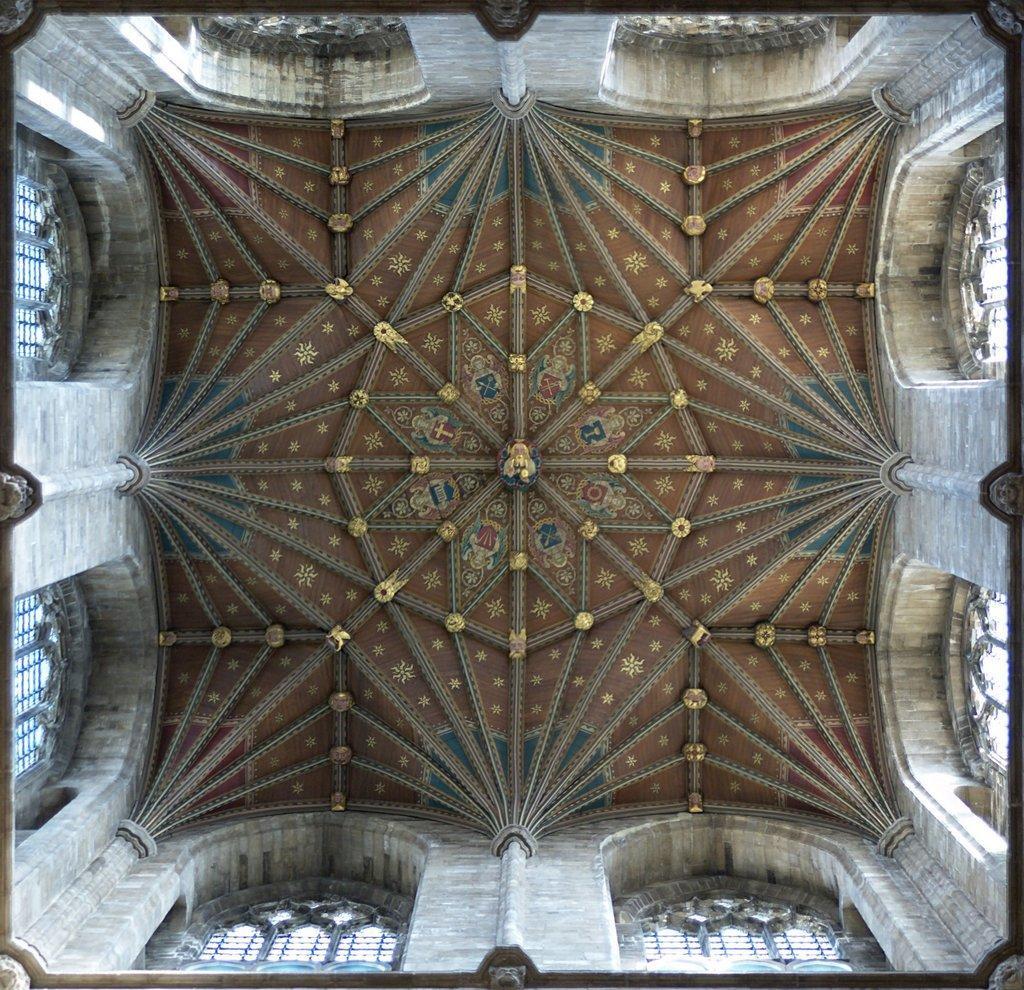Can you describe this image briefly? In this image we can see an inside view of a building, in which we can see some windows, pillars and the roof. 